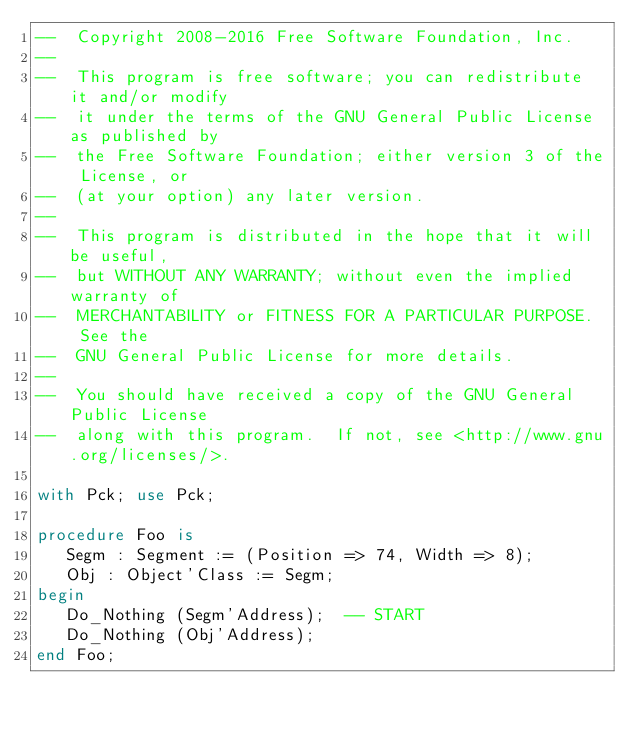Convert code to text. <code><loc_0><loc_0><loc_500><loc_500><_Ada_>--  Copyright 2008-2016 Free Software Foundation, Inc.
--
--  This program is free software; you can redistribute it and/or modify
--  it under the terms of the GNU General Public License as published by
--  the Free Software Foundation; either version 3 of the License, or
--  (at your option) any later version.
--
--  This program is distributed in the hope that it will be useful,
--  but WITHOUT ANY WARRANTY; without even the implied warranty of
--  MERCHANTABILITY or FITNESS FOR A PARTICULAR PURPOSE.  See the
--  GNU General Public License for more details.
--
--  You should have received a copy of the GNU General Public License
--  along with this program.  If not, see <http://www.gnu.org/licenses/>.

with Pck; use Pck;

procedure Foo is
   Segm : Segment := (Position => 74, Width => 8);
   Obj : Object'Class := Segm;
begin
   Do_Nothing (Segm'Address);  -- START
   Do_Nothing (Obj'Address);
end Foo;
</code> 